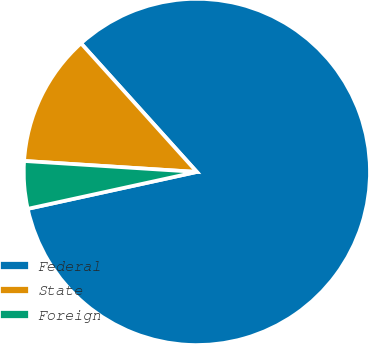<chart> <loc_0><loc_0><loc_500><loc_500><pie_chart><fcel>Federal<fcel>State<fcel>Foreign<nl><fcel>83.25%<fcel>12.32%<fcel>4.43%<nl></chart> 